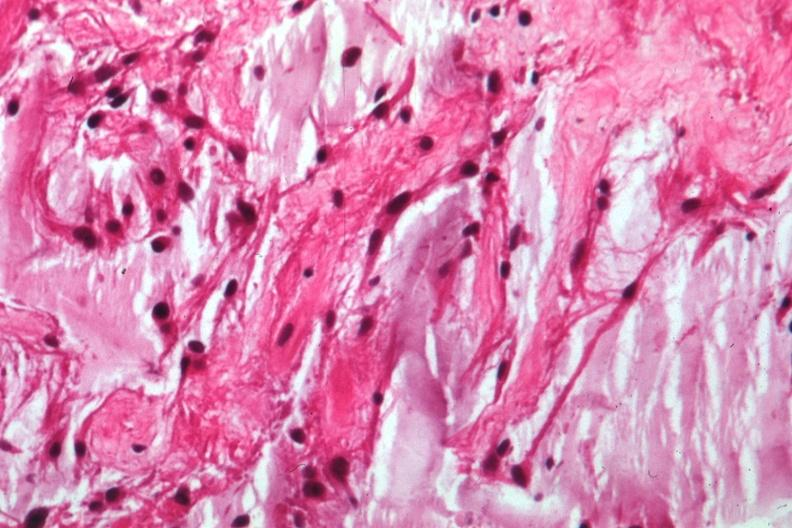s vessel present?
Answer the question using a single word or phrase. No 